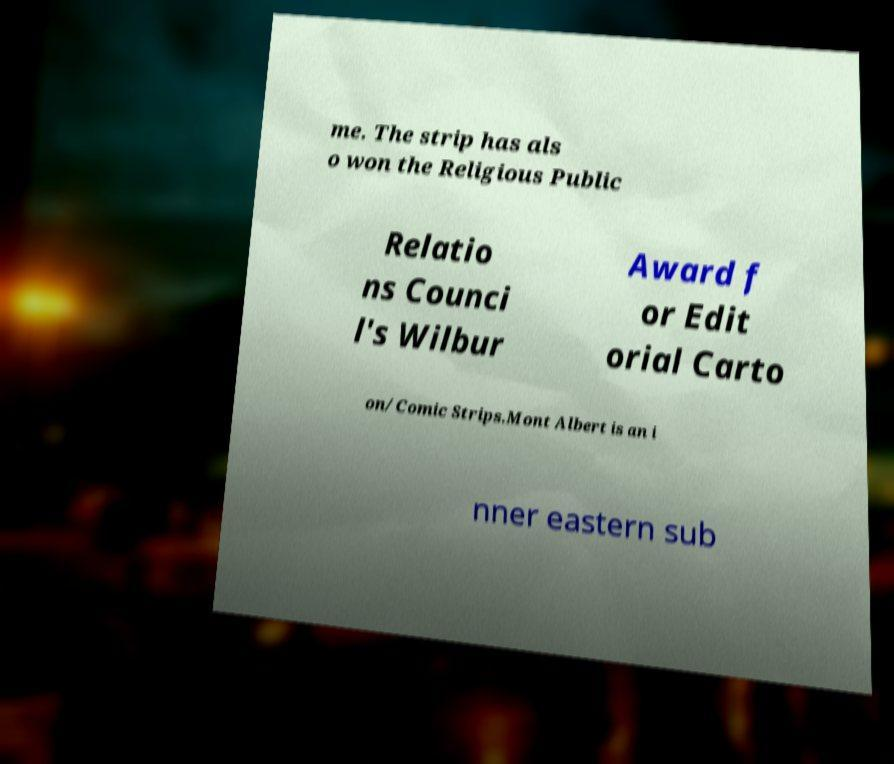Could you assist in decoding the text presented in this image and type it out clearly? me. The strip has als o won the Religious Public Relatio ns Counci l's Wilbur Award f or Edit orial Carto on/Comic Strips.Mont Albert is an i nner eastern sub 